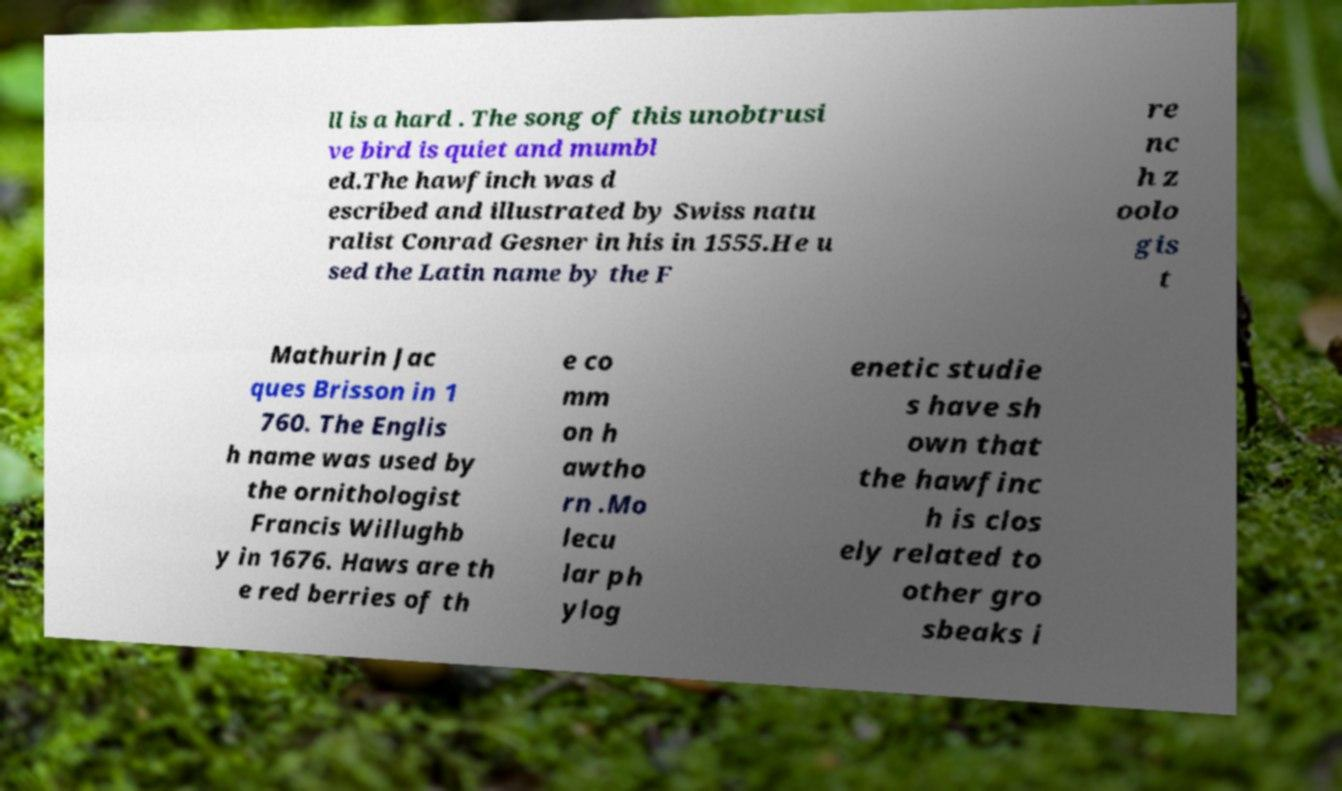Could you extract and type out the text from this image? ll is a hard . The song of this unobtrusi ve bird is quiet and mumbl ed.The hawfinch was d escribed and illustrated by Swiss natu ralist Conrad Gesner in his in 1555.He u sed the Latin name by the F re nc h z oolo gis t Mathurin Jac ques Brisson in 1 760. The Englis h name was used by the ornithologist Francis Willughb y in 1676. Haws are th e red berries of th e co mm on h awtho rn .Mo lecu lar ph ylog enetic studie s have sh own that the hawfinc h is clos ely related to other gro sbeaks i 